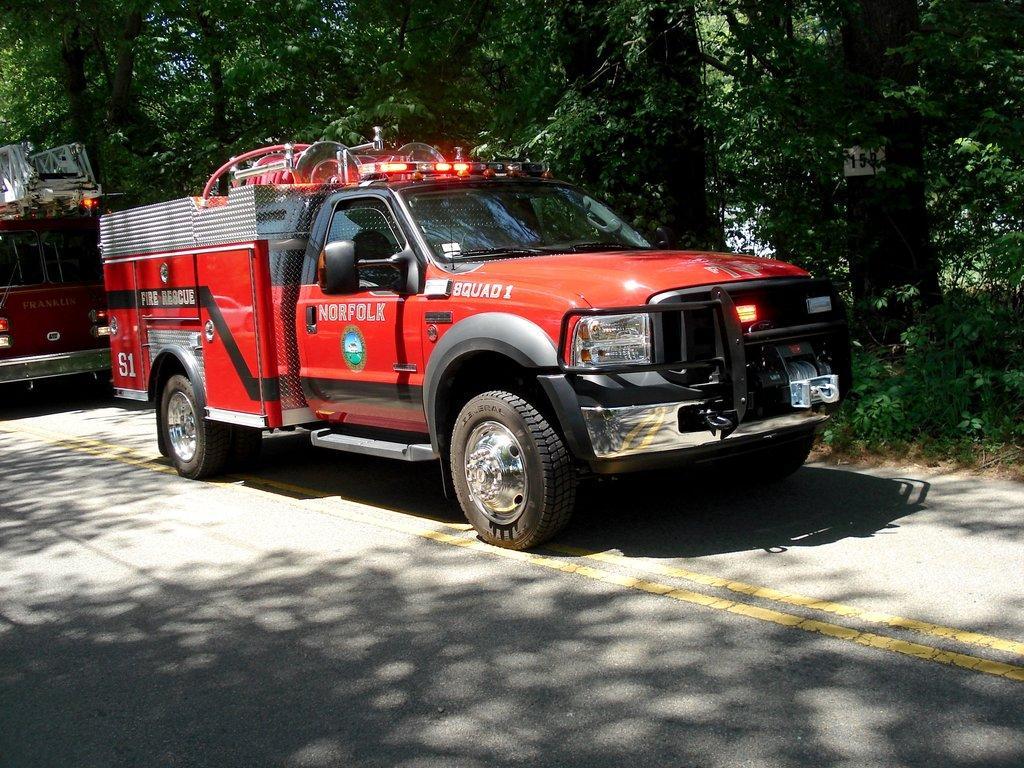Describe this image in one or two sentences. Here I can see two vehicles on the road. This vehicle is facing towards the right side. In the background there are many trees. 